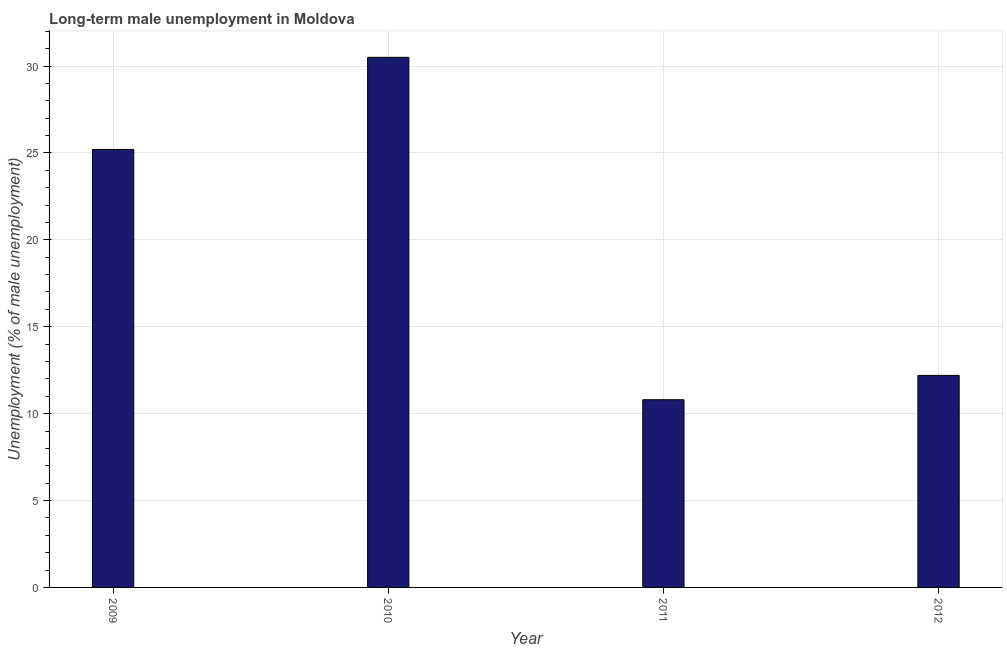Does the graph contain any zero values?
Give a very brief answer. No. Does the graph contain grids?
Ensure brevity in your answer.  Yes. What is the title of the graph?
Your response must be concise. Long-term male unemployment in Moldova. What is the label or title of the Y-axis?
Provide a short and direct response. Unemployment (% of male unemployment). What is the long-term male unemployment in 2010?
Ensure brevity in your answer.  30.5. Across all years, what is the maximum long-term male unemployment?
Your answer should be compact. 30.5. Across all years, what is the minimum long-term male unemployment?
Provide a short and direct response. 10.8. In which year was the long-term male unemployment maximum?
Make the answer very short. 2010. What is the sum of the long-term male unemployment?
Your answer should be compact. 78.7. What is the average long-term male unemployment per year?
Make the answer very short. 19.68. What is the median long-term male unemployment?
Your response must be concise. 18.7. Do a majority of the years between 2010 and 2012 (inclusive) have long-term male unemployment greater than 27 %?
Provide a short and direct response. No. Is the long-term male unemployment in 2009 less than that in 2010?
Make the answer very short. Yes. Is the difference between the long-term male unemployment in 2009 and 2012 greater than the difference between any two years?
Keep it short and to the point. No. Is the sum of the long-term male unemployment in 2009 and 2010 greater than the maximum long-term male unemployment across all years?
Provide a succinct answer. Yes. In how many years, is the long-term male unemployment greater than the average long-term male unemployment taken over all years?
Offer a very short reply. 2. Are all the bars in the graph horizontal?
Keep it short and to the point. No. What is the difference between two consecutive major ticks on the Y-axis?
Keep it short and to the point. 5. Are the values on the major ticks of Y-axis written in scientific E-notation?
Provide a succinct answer. No. What is the Unemployment (% of male unemployment) of 2009?
Your answer should be very brief. 25.2. What is the Unemployment (% of male unemployment) of 2010?
Your answer should be compact. 30.5. What is the Unemployment (% of male unemployment) of 2011?
Offer a terse response. 10.8. What is the Unemployment (% of male unemployment) of 2012?
Ensure brevity in your answer.  12.2. What is the difference between the Unemployment (% of male unemployment) in 2009 and 2010?
Provide a succinct answer. -5.3. What is the difference between the Unemployment (% of male unemployment) in 2010 and 2011?
Give a very brief answer. 19.7. What is the difference between the Unemployment (% of male unemployment) in 2010 and 2012?
Ensure brevity in your answer.  18.3. What is the ratio of the Unemployment (% of male unemployment) in 2009 to that in 2010?
Your response must be concise. 0.83. What is the ratio of the Unemployment (% of male unemployment) in 2009 to that in 2011?
Your answer should be compact. 2.33. What is the ratio of the Unemployment (% of male unemployment) in 2009 to that in 2012?
Your answer should be compact. 2.07. What is the ratio of the Unemployment (% of male unemployment) in 2010 to that in 2011?
Make the answer very short. 2.82. What is the ratio of the Unemployment (% of male unemployment) in 2011 to that in 2012?
Ensure brevity in your answer.  0.89. 